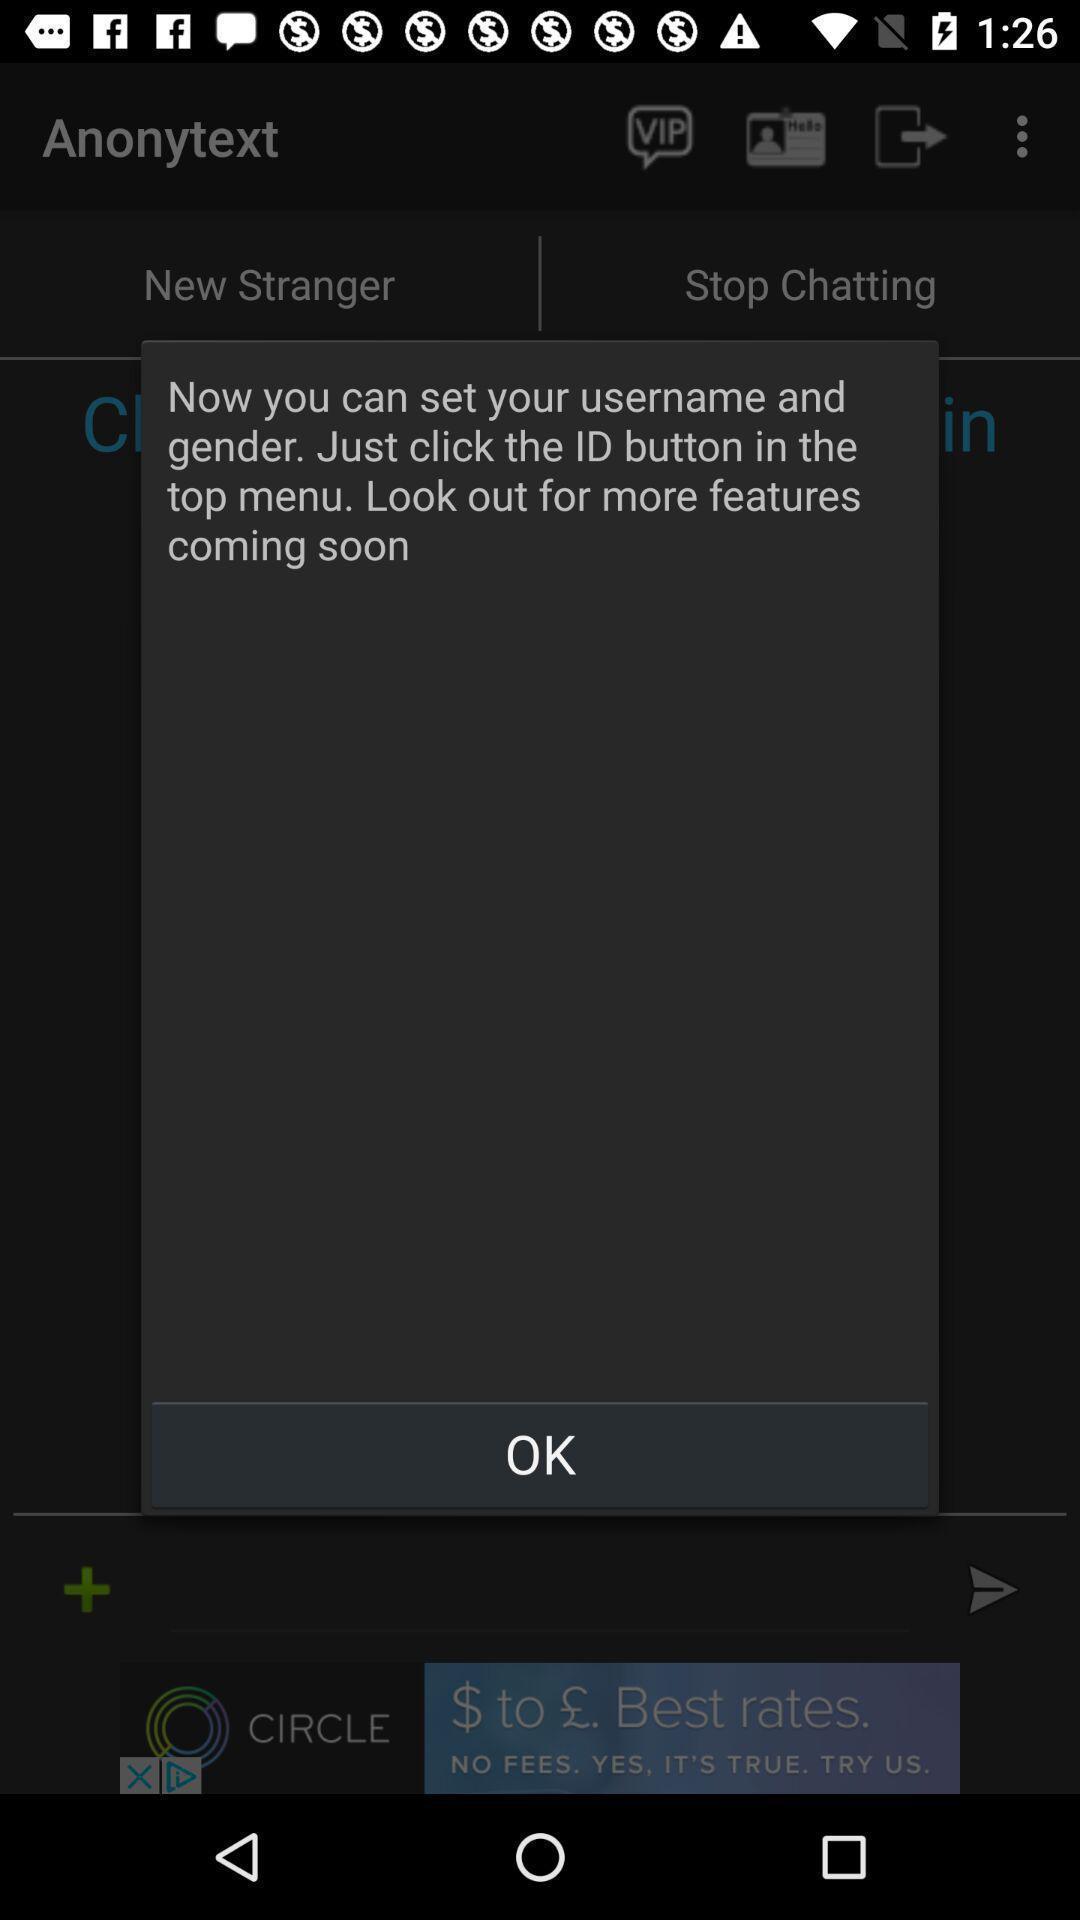Give me a summary of this screen capture. Pop up to set username and gender. 